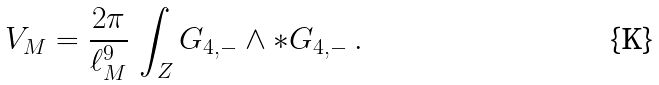Convert formula to latex. <formula><loc_0><loc_0><loc_500><loc_500>V _ { M } = \frac { 2 \pi } { \ell _ { M } ^ { 9 } } \, \int _ { Z } G _ { 4 , - } \wedge * G _ { 4 , - } \, .</formula> 